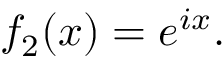<formula> <loc_0><loc_0><loc_500><loc_500>f _ { 2 } ( x ) = e ^ { i x } .</formula> 